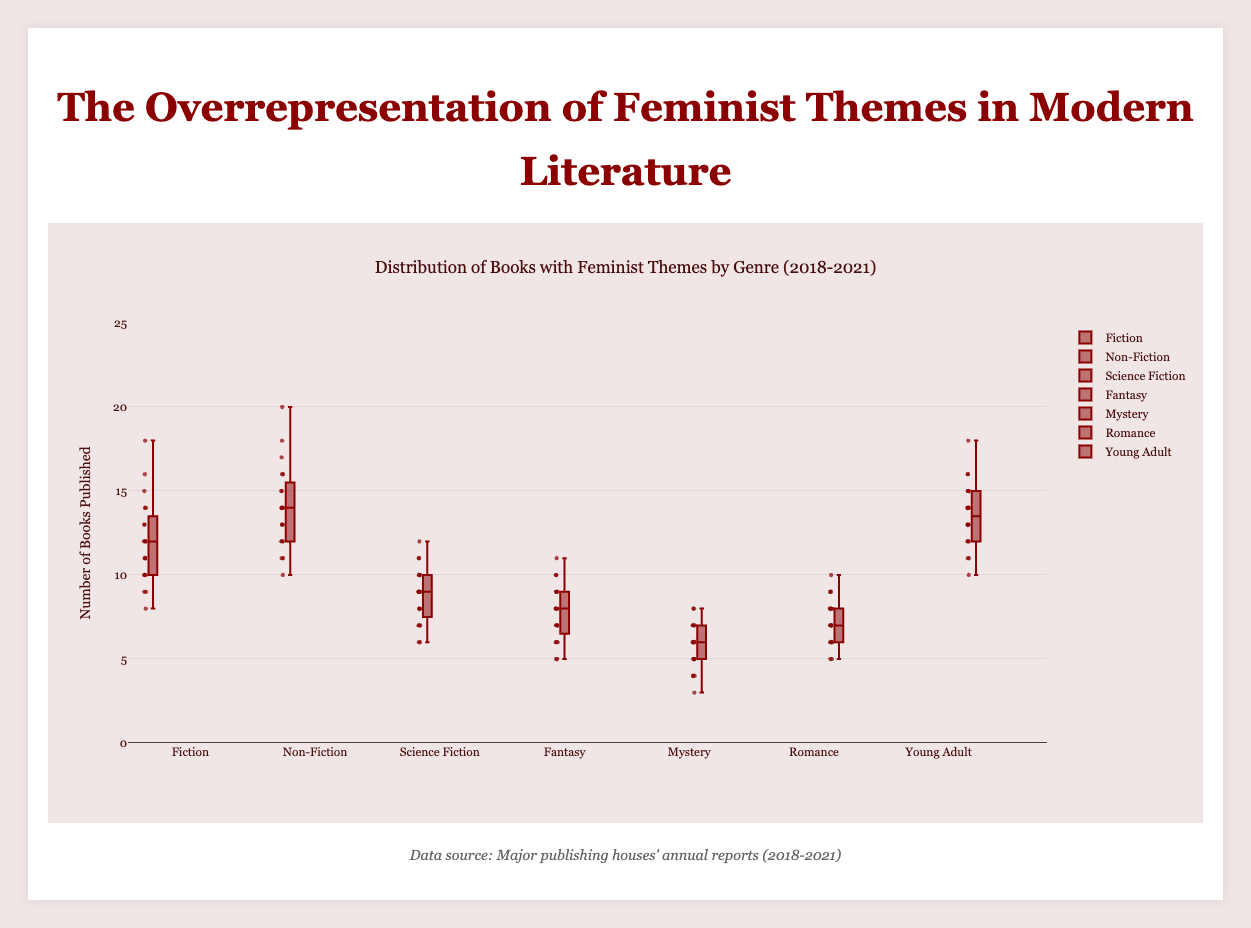What is the title of the plot? The title is usually located at the top of the plot. In this case, it would be referring to the main narrative of the displayed data.
Answer: Distribution of Books with Feminist Themes by Genre (2018-2021) How many genres are featured in the plot? The genres are explicitly listed on the plot. By counting them, we can determine how many genres are included.
Answer: 7 Which genre has the highest median number of books published annually? Identify the central mark within each box plot that represents the median value, then compare which one is the highest.
Answer: Non-Fiction In which genre is the variation in the number of books published the greatest? Look at the interquartile range (the box length), the presence of outliers, and the whisker length to determine which genre has the broadest spread.
Answer: Non-Fiction What is the interquartile range (IQR) for the genre with the highest published books? Examine the distance between the first quartile (Q1) and the third quartile (Q3) for the genre with the highest median, which is Non-Fiction. Estimate Q3 - Q1 visually. Q1 is around 14, and Q3 is around 19, so the IQR is 19 - 14.
Answer: 5 Which genres contain outliers and how can you identify them? Outliers are individual points outside the whiskers of the box plots. Identify any genres where such points are observed.
Answer: Science Fiction, Fantasy, Non-Fiction Compare the number of feminist-themed books published in Science Fiction and Young Adult genres. Which genre has a higher median number of published books? Look at the median line within the box plots for both Science Fiction and Young Adult genres and compare them.
Answer: Young Adult Between Penguin Random House and Simon & Schuster, which publisher has a wider range of feminist-themed books in the Fiction genre? Calculate the range by looking at the minimum and maximum values for the Fiction genre box plots of both publishers. Compare these ranges.
Answer: Penguin Random House What trend can you observe in the number of feminist-themed books published from 2018 to 2021 in the Romance genre across all publishers? Look at the general direction of the data points and the median line for the Romance genre over the years 2018 to 2021 to identify any increasing or decreasing trends.
Answer: Increasing trend 